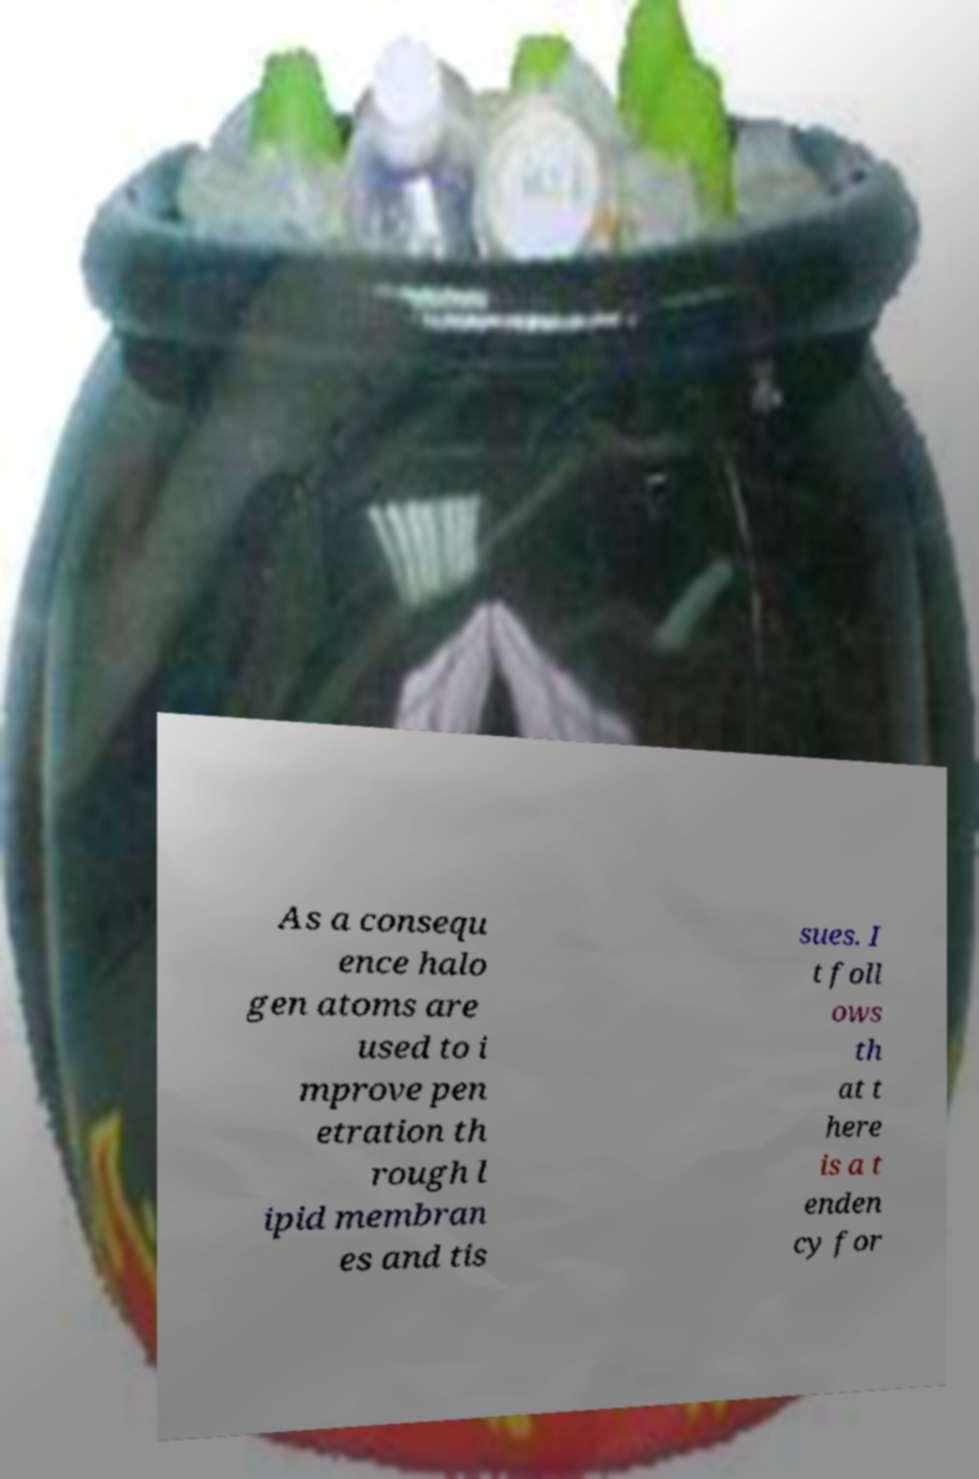What messages or text are displayed in this image? I need them in a readable, typed format. As a consequ ence halo gen atoms are used to i mprove pen etration th rough l ipid membran es and tis sues. I t foll ows th at t here is a t enden cy for 